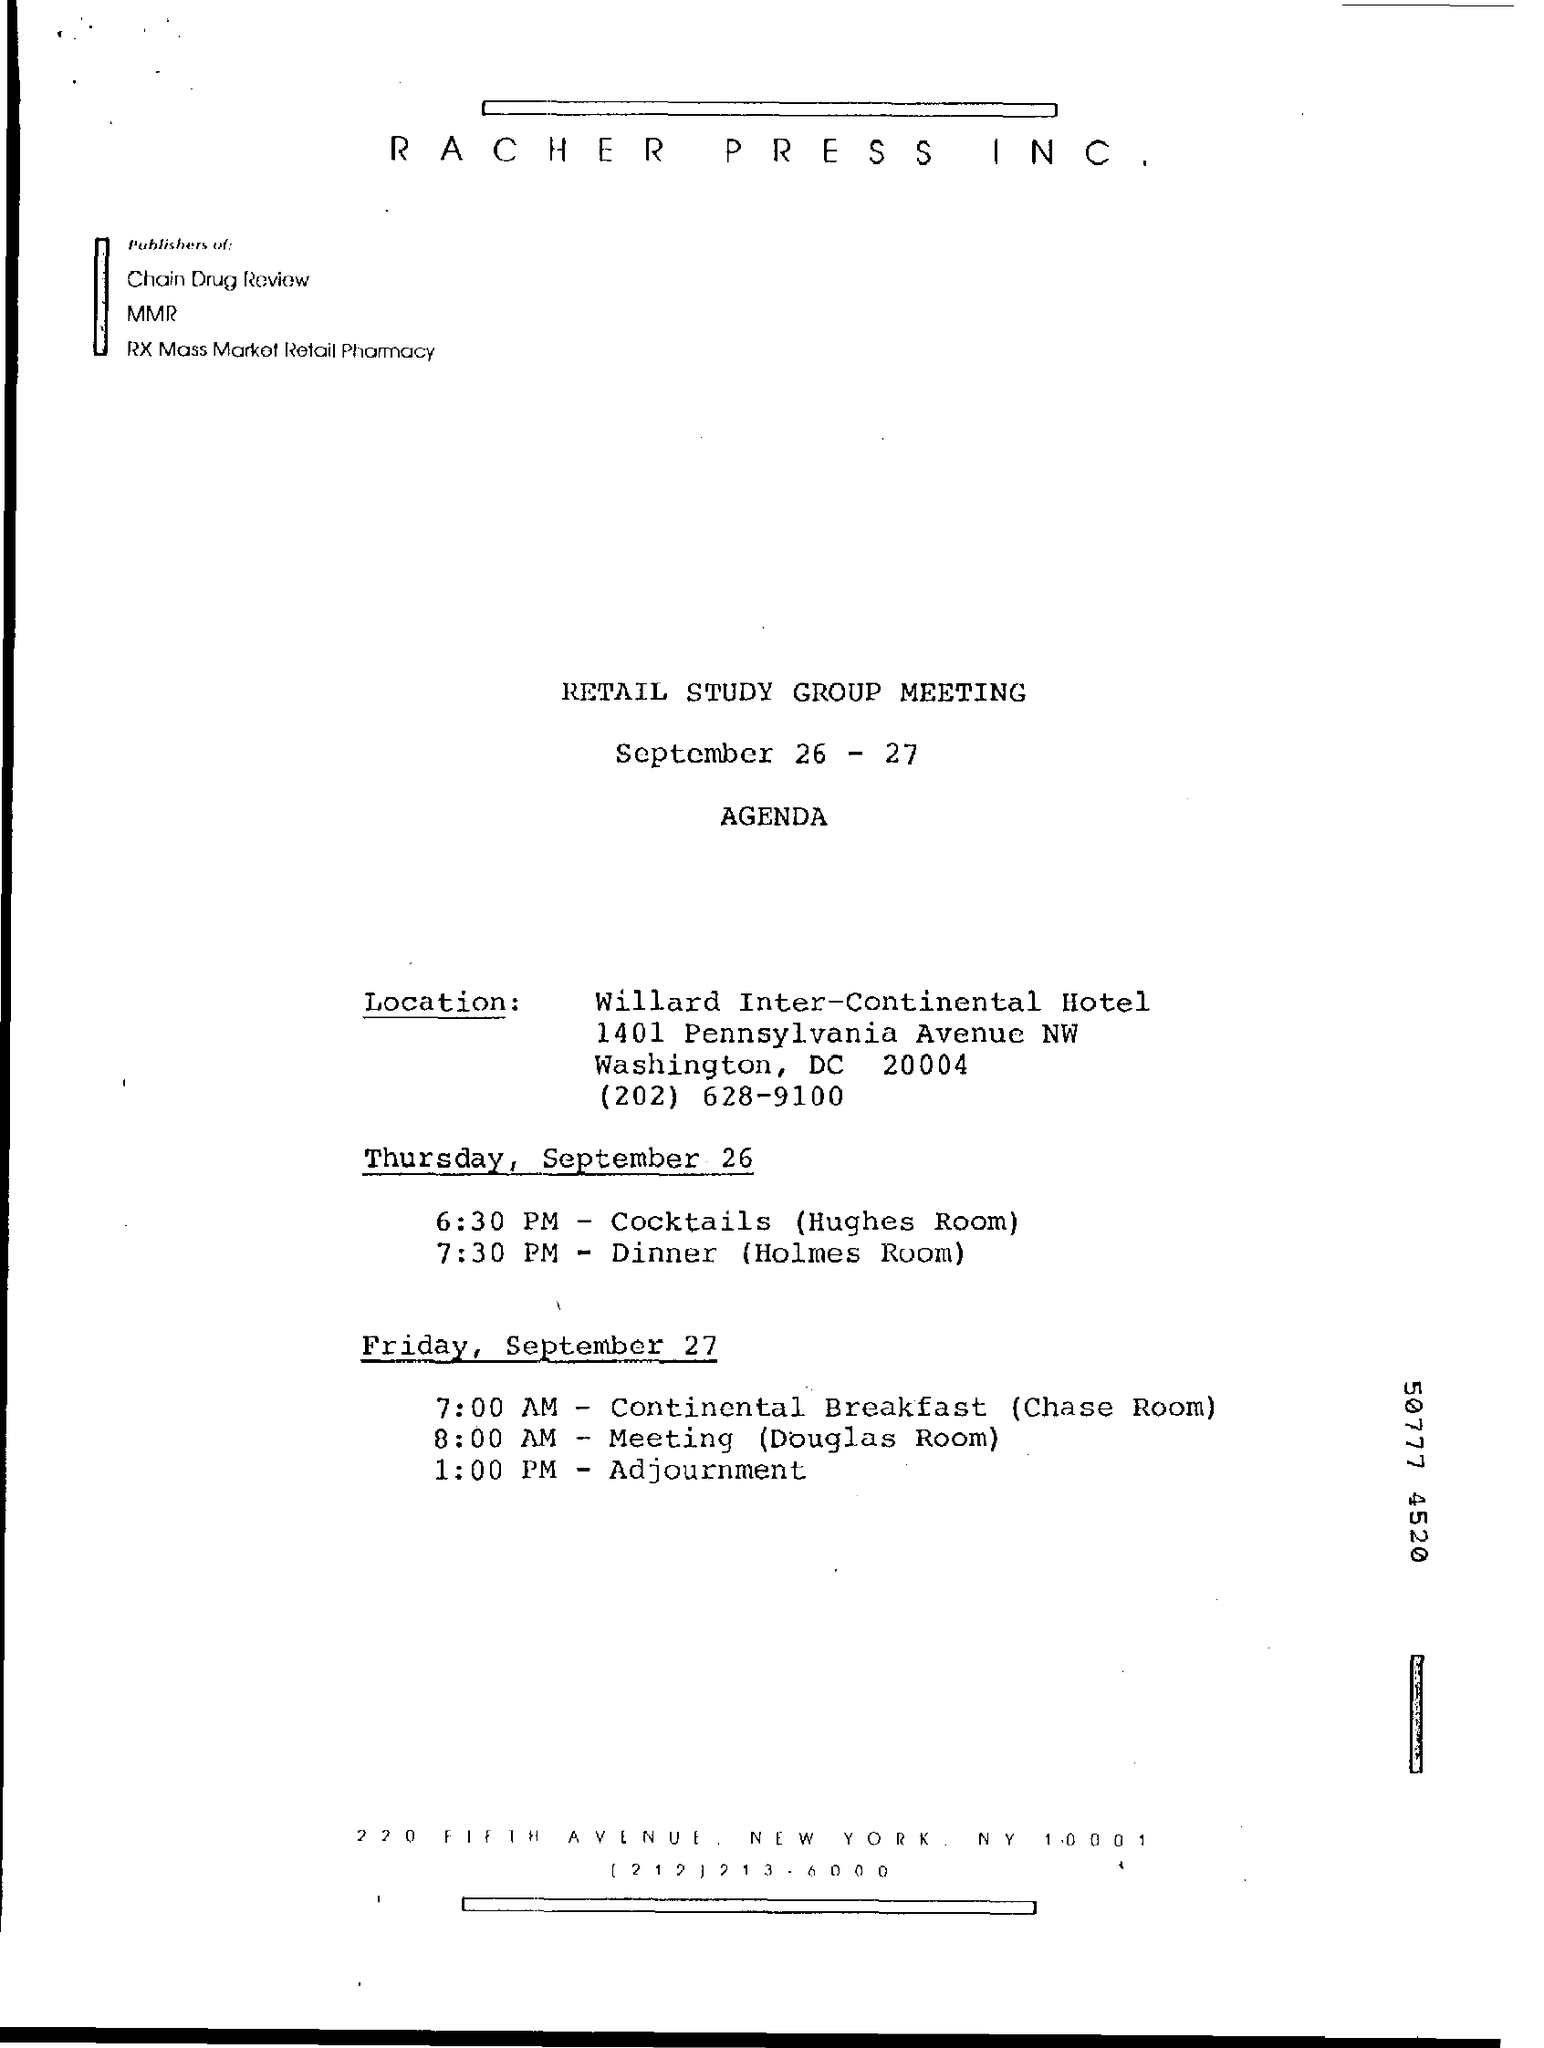On which dates the retail study group meeting was held ?
Make the answer very short. SEPTEMBER 26-27. At what time cocktails are served on thursday , september 26 ?
Provide a short and direct response. 6:30 PM. In which room cocktails are served ?
Your response must be concise. Hughes room. At what time dinner is served on thursday september 26 ?
Offer a terse response. 7:30 PM. On which date continental breakfast is served ?
Give a very brief answer. Friday , september 27. At what time meeting is held ?
Give a very brief answer. 8:00 AM. In which room meeting was held ?
Provide a succinct answer. Douglas Room. In which room continental breakfast is served ?
Make the answer very short. Chase room. 